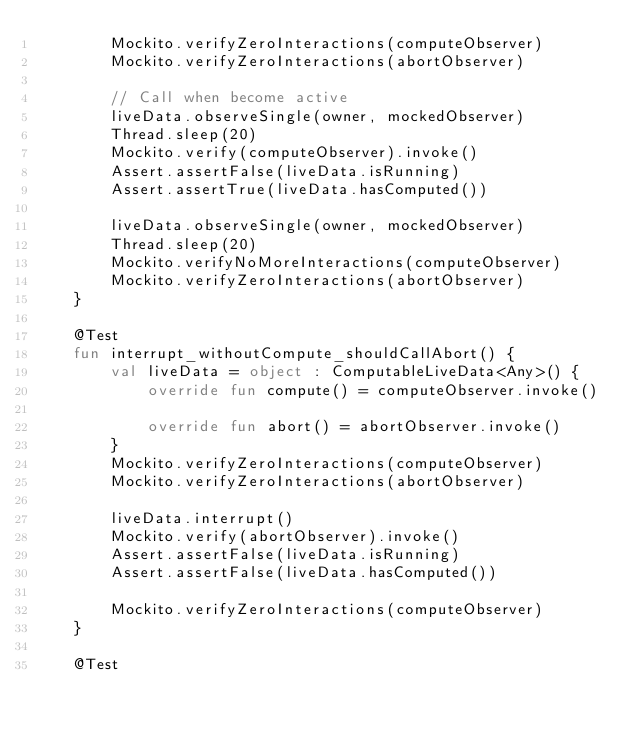Convert code to text. <code><loc_0><loc_0><loc_500><loc_500><_Kotlin_>        Mockito.verifyZeroInteractions(computeObserver)
        Mockito.verifyZeroInteractions(abortObserver)

        // Call when become active
        liveData.observeSingle(owner, mockedObserver)
        Thread.sleep(20)
        Mockito.verify(computeObserver).invoke()
        Assert.assertFalse(liveData.isRunning)
        Assert.assertTrue(liveData.hasComputed())

        liveData.observeSingle(owner, mockedObserver)
        Thread.sleep(20)
        Mockito.verifyNoMoreInteractions(computeObserver)
        Mockito.verifyZeroInteractions(abortObserver)
    }

    @Test
    fun interrupt_withoutCompute_shouldCallAbort() {
        val liveData = object : ComputableLiveData<Any>() {
            override fun compute() = computeObserver.invoke()

            override fun abort() = abortObserver.invoke()
        }
        Mockito.verifyZeroInteractions(computeObserver)
        Mockito.verifyZeroInteractions(abortObserver)

        liveData.interrupt()
        Mockito.verify(abortObserver).invoke()
        Assert.assertFalse(liveData.isRunning)
        Assert.assertFalse(liveData.hasComputed())

        Mockito.verifyZeroInteractions(computeObserver)
    }

    @Test</code> 